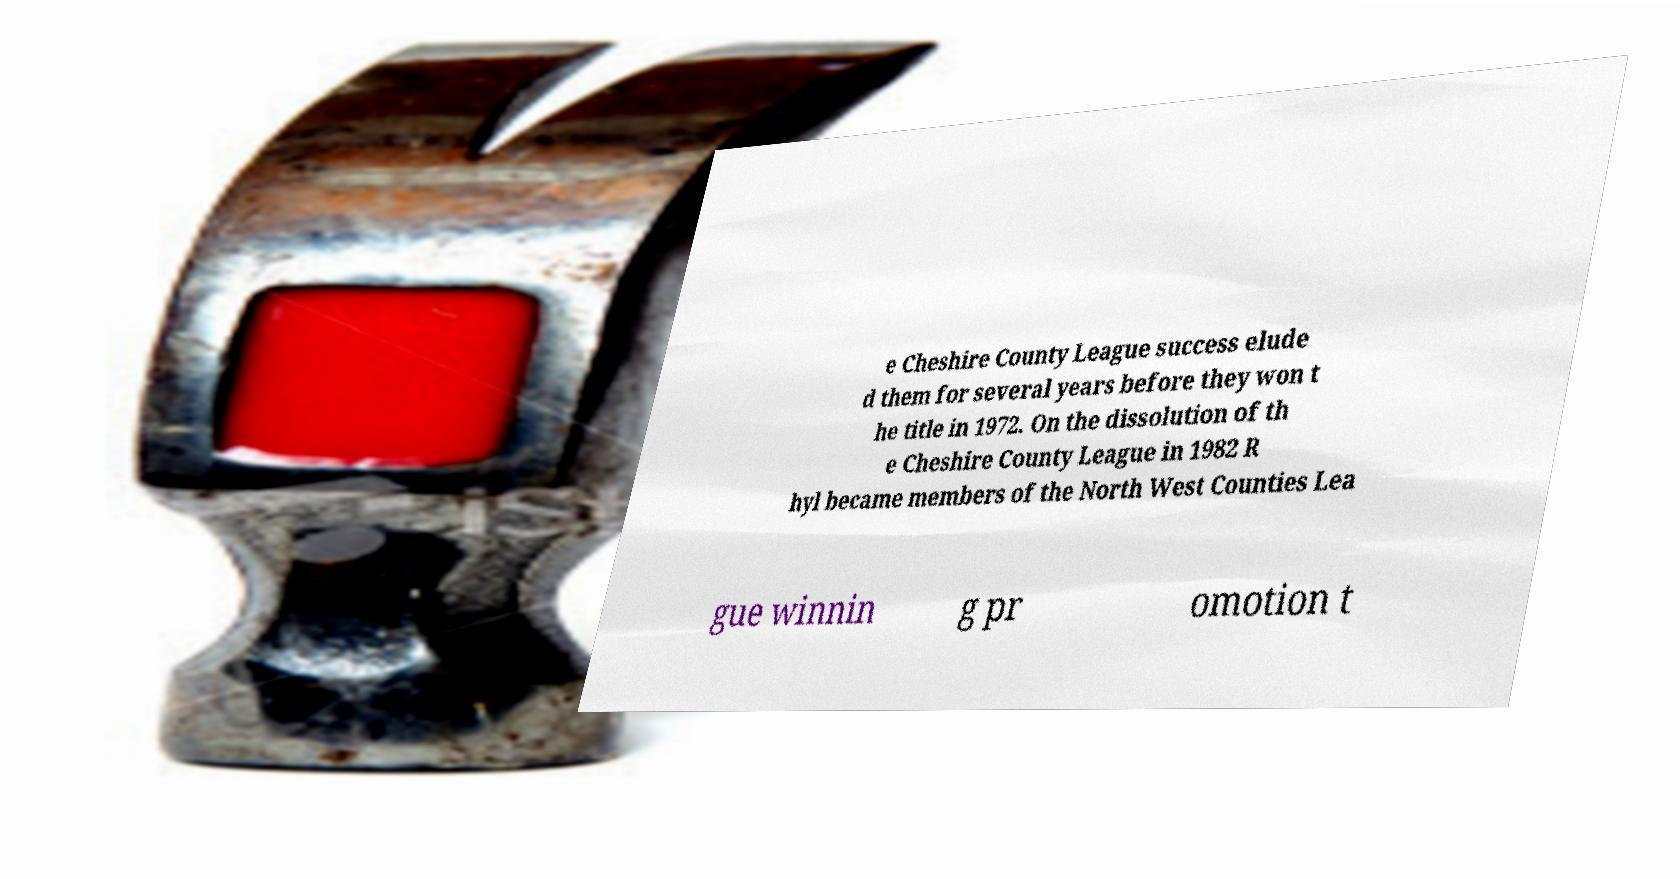Can you accurately transcribe the text from the provided image for me? e Cheshire County League success elude d them for several years before they won t he title in 1972. On the dissolution of th e Cheshire County League in 1982 R hyl became members of the North West Counties Lea gue winnin g pr omotion t 